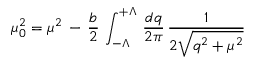Convert formula to latex. <formula><loc_0><loc_0><loc_500><loc_500>\mu _ { 0 } ^ { 2 } = \mu ^ { 2 } \, - \, { \frac { b } { 2 } } \, \int _ { - \Lambda } ^ { + \Lambda } \, { \frac { d q } { 2 \pi } } \, { \frac { 1 } { 2 \sqrt { q ^ { 2 } + \mu ^ { 2 } } } }</formula> 